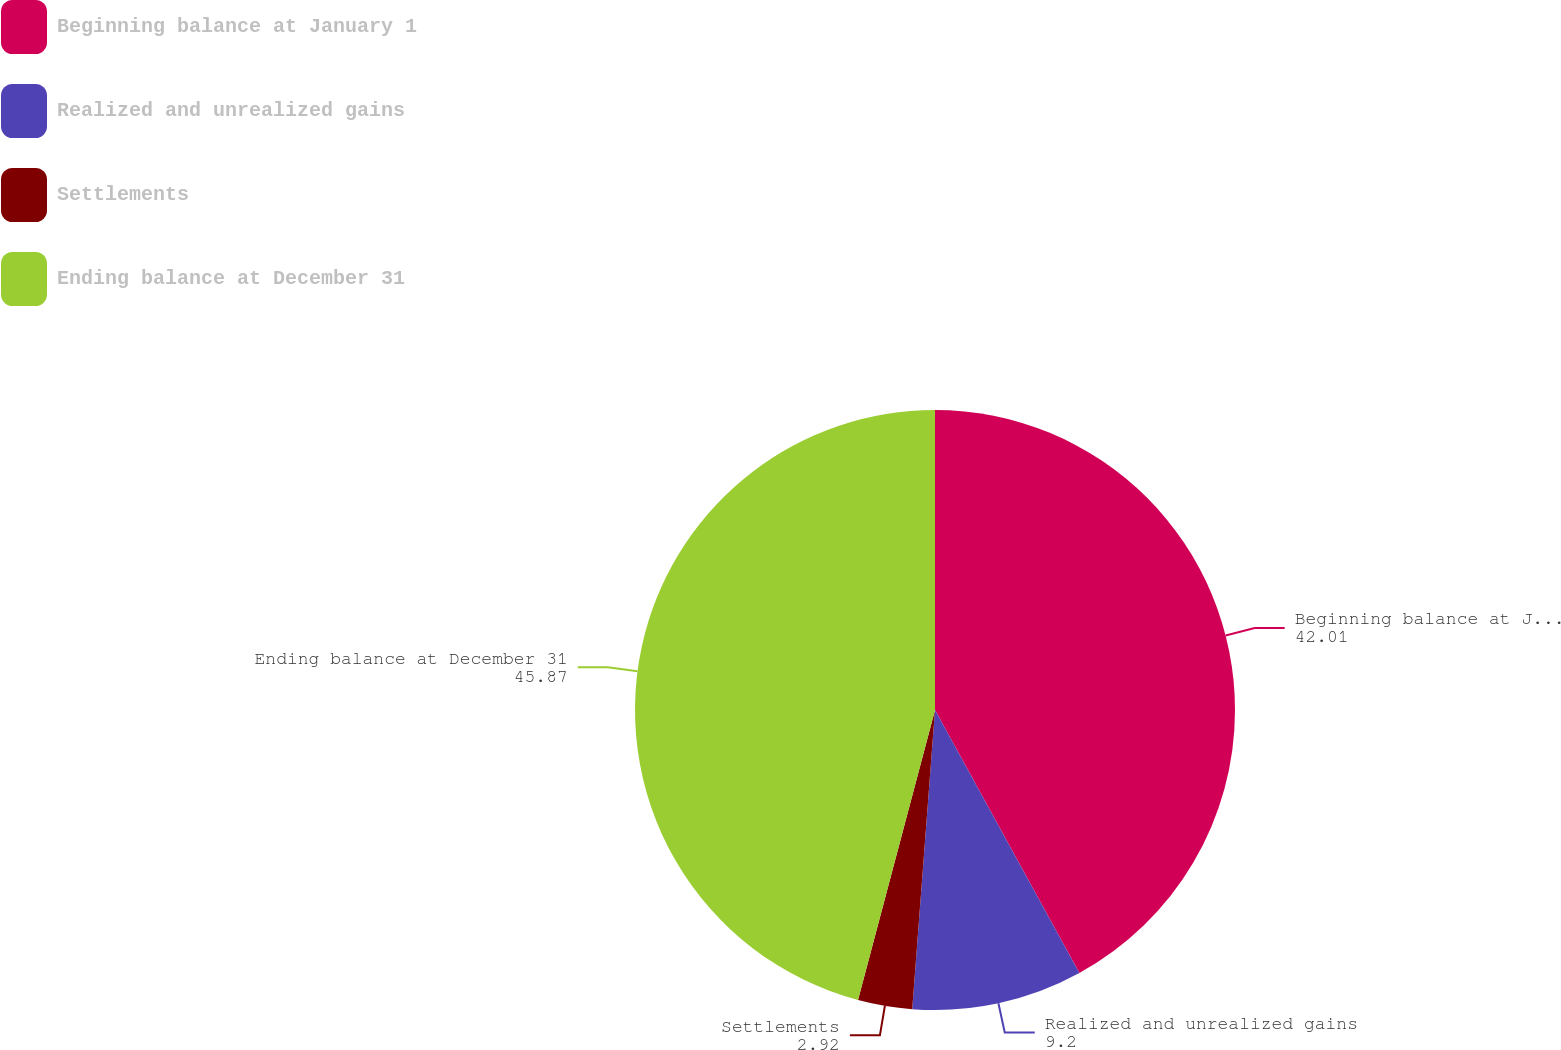<chart> <loc_0><loc_0><loc_500><loc_500><pie_chart><fcel>Beginning balance at January 1<fcel>Realized and unrealized gains<fcel>Settlements<fcel>Ending balance at December 31<nl><fcel>42.01%<fcel>9.2%<fcel>2.92%<fcel>45.87%<nl></chart> 